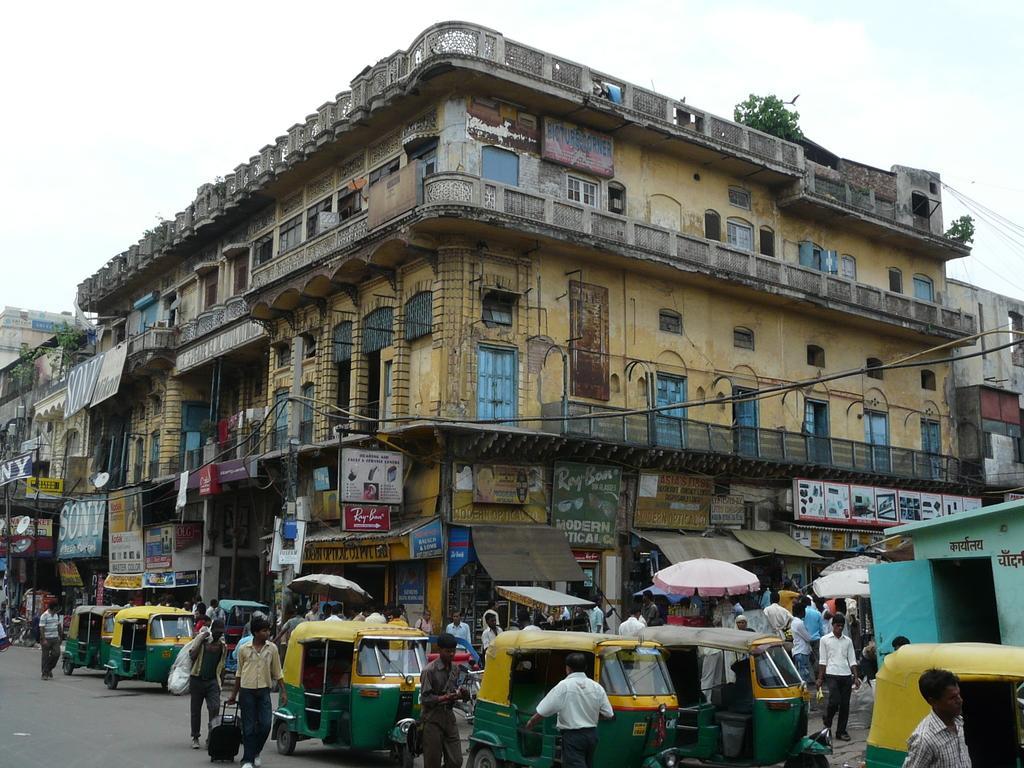Could you give a brief overview of what you see in this image? In this image there are buildings, boards, hoardings, umbrellas, vehicles, people, leaves, sky and objects. Something is written on the boards. Vehicles and people are on the road. Few people are holding objects. 